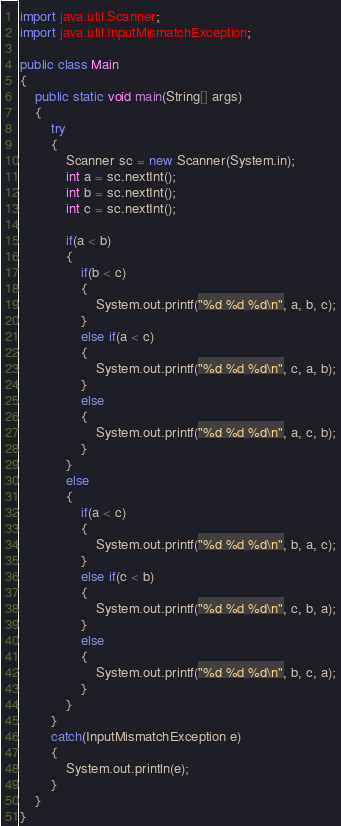Convert code to text. <code><loc_0><loc_0><loc_500><loc_500><_Java_>import java.util.Scanner;
import java.util.InputMismatchException;

public class Main
{
	public static void main(String[] args)
	{
		try
		{
			Scanner sc = new Scanner(System.in);
			int a = sc.nextInt();
			int b = sc.nextInt();
			int c = sc.nextInt();
			
			if(a < b)
			{
				if(b < c)
				{
					System.out.printf("%d %d %d\n", a, b, c);
				}
				else if(a < c)
				{
					System.out.printf("%d %d %d\n", c, a, b);
				}
				else
				{
					System.out.printf("%d %d %d\n", a, c, b);
				}
			}
			else
			{
				if(a < c)
				{
					System.out.printf("%d %d %d\n", b, a, c);
				}
				else if(c < b)
				{
					System.out.printf("%d %d %d\n", c, b, a);
				}
				else
				{
					System.out.printf("%d %d %d\n", b, c, a);
				}
			}
		}
		catch(InputMismatchException e)
		{
			System.out.println(e);
		}
	}
}</code> 